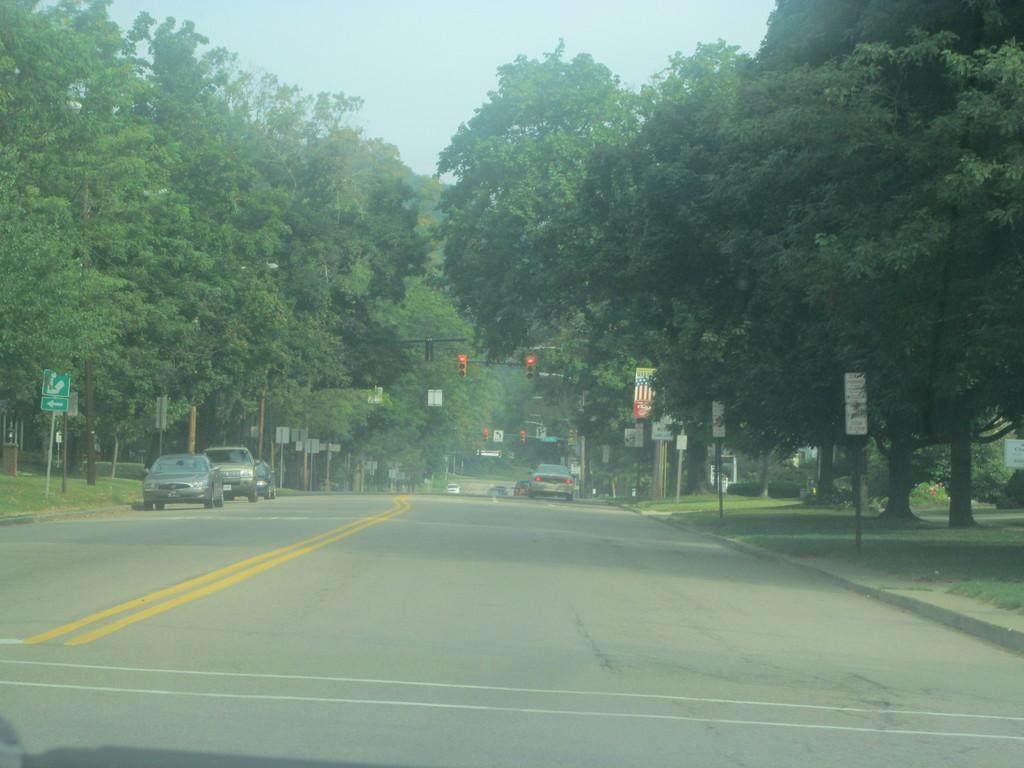What is in the foreground of the image? There is a road in the foreground of the image. What can be seen in the background of the image? There are vehicles, poles, posters, trees, and the sky visible in the background of the image. Can you describe the vehicles in the image? The vehicles are in the background of the image, but their specific types or models cannot be determined from the provided facts. What type of structures are the poles in the image? The poles in the image are in the background, but their specific purpose or design cannot be determined from the provided facts. What type of bird can be seen tasting the road in the image? There is no bird present in the image, and the road is not being tasted by any creature. 